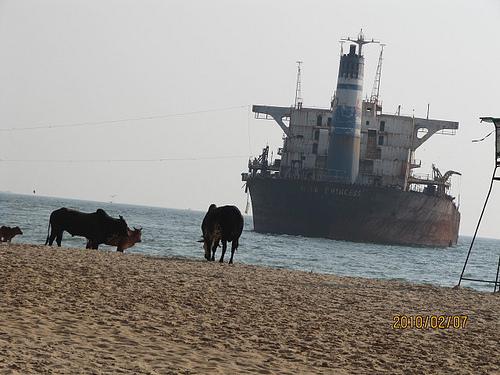Is there anything for the cows to eat?
Short answer required. No. What day was this pic took?
Keep it brief. 2010/02/07. How many animals are shown?
Quick response, please. 4. Where is the ship?
Quick response, please. In water. 